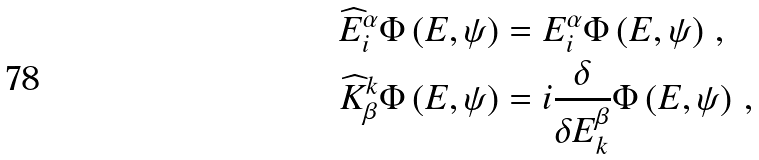<formula> <loc_0><loc_0><loc_500><loc_500>\widehat { E } ^ { \alpha } _ { i } \Phi \left ( E , \psi \right ) & = E ^ { \alpha } _ { i } \Phi \left ( E , \psi \right ) \, , \quad \\ \widehat { K } _ { \beta } ^ { k } \Phi \left ( E , \psi \right ) & = i \frac { \delta } { \delta E ^ { \beta } _ { k } } \Phi \left ( E , \psi \right ) \, ,</formula> 